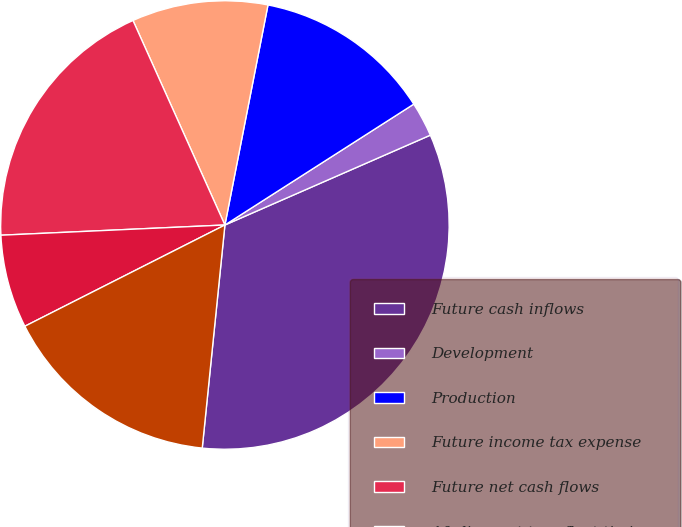Convert chart to OTSL. <chart><loc_0><loc_0><loc_500><loc_500><pie_chart><fcel>Future cash inflows<fcel>Development<fcel>Production<fcel>Future income tax expense<fcel>Future net cash flows<fcel>10 discount to reflect timing<fcel>Standardized measure of<nl><fcel>33.17%<fcel>2.5%<fcel>12.86%<fcel>9.8%<fcel>19.0%<fcel>6.73%<fcel>15.93%<nl></chart> 